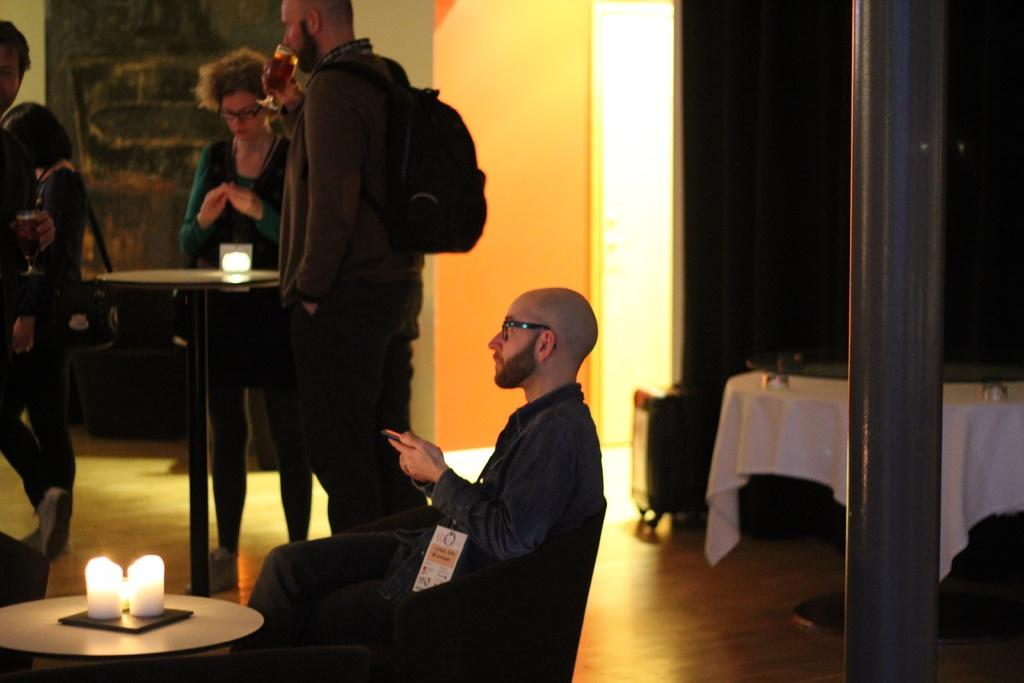What is the person in the image doing? The person is sitting on a chair. Where is the chair located in the image? The chair is placed on a table. What can be seen on the table besides the chair? There is a candle on the table. What is the woman in the image doing? There is no information about what the woman is doing in the image. Who is holding a glass in the image? There is a person holding a glass in the image. What is the title of the book the person is reading in the image? There is no book present in the image, so there is no title to mention. 